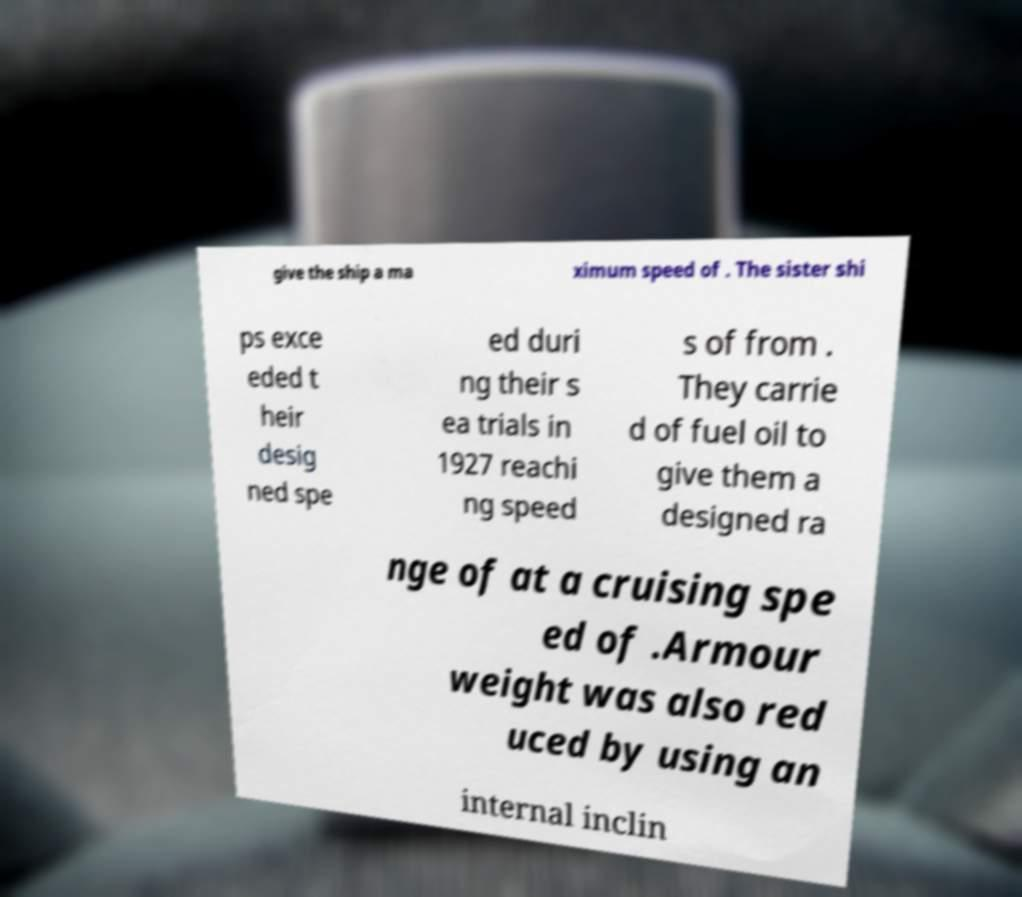For documentation purposes, I need the text within this image transcribed. Could you provide that? give the ship a ma ximum speed of . The sister shi ps exce eded t heir desig ned spe ed duri ng their s ea trials in 1927 reachi ng speed s of from . They carrie d of fuel oil to give them a designed ra nge of at a cruising spe ed of .Armour weight was also red uced by using an internal inclin 